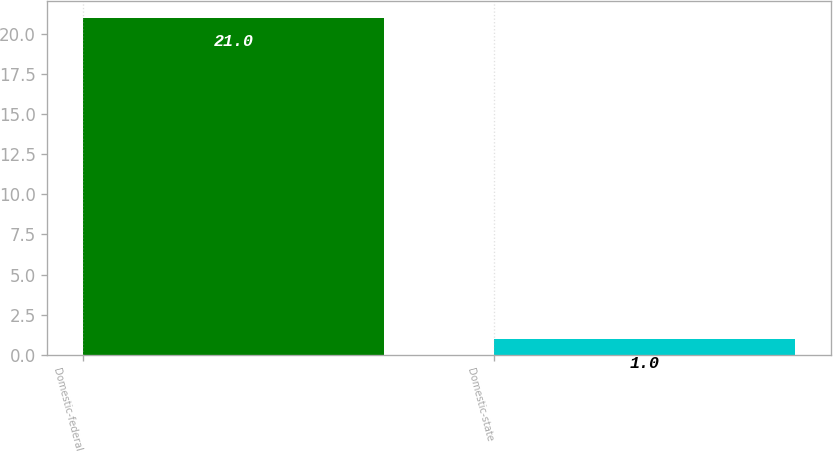Convert chart. <chart><loc_0><loc_0><loc_500><loc_500><bar_chart><fcel>Domestic-federal<fcel>Domestic-state<nl><fcel>21<fcel>1<nl></chart> 